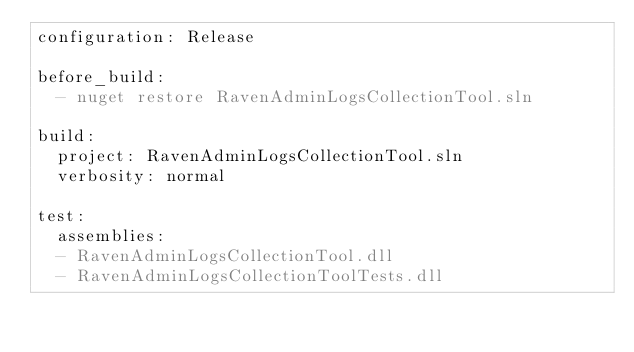<code> <loc_0><loc_0><loc_500><loc_500><_YAML_>configuration: Release

before_build:
  - nuget restore RavenAdminLogsCollectionTool.sln

build:
  project: RavenAdminLogsCollectionTool.sln
  verbosity: normal

test:
  assemblies:
  - RavenAdminLogsCollectionTool.dll
  - RavenAdminLogsCollectionToolTests.dll</code> 